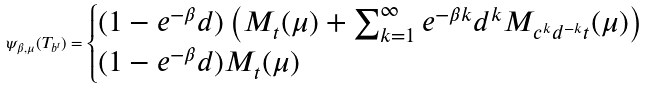<formula> <loc_0><loc_0><loc_500><loc_500>\psi _ { \beta , \mu } ( T _ { b ^ { t } } ) = \begin{cases} ( 1 - e ^ { - \beta } d ) \left ( M _ { t } ( \mu ) + \sum _ { k = 1 } ^ { \infty } e ^ { - \beta k } d ^ { k } M _ { c ^ { k } d ^ { - k } t } ( \mu ) \right ) & \\ ( 1 - e ^ { - \beta } d ) M _ { t } ( \mu ) & \end{cases}</formula> 